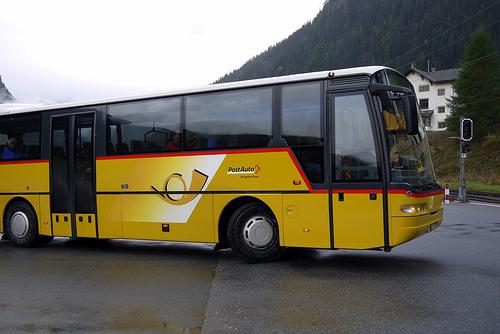Question: what color are the trees?
Choices:
A. Brown.
B. Red.
C. Green.
D. Orange.
Answer with the letter. Answer: C Question: where was the picture taken?
Choices:
A. Near the truck.
B. In a street.
C. At the tracks.
D. In front of the buildings.
Answer with the letter. Answer: B Question: what color is the pavement?
Choices:
A. Grey.
B. White.
C. Brown.
D. Black.
Answer with the letter. Answer: D Question: how many buses are there?
Choices:
A. 1.
B. 2.
C. 3.
D. 4.
Answer with the letter. Answer: A Question: what color is the sky?
Choices:
A. Black.
B. Red.
C. Blue.
D. Gray.
Answer with the letter. Answer: D 